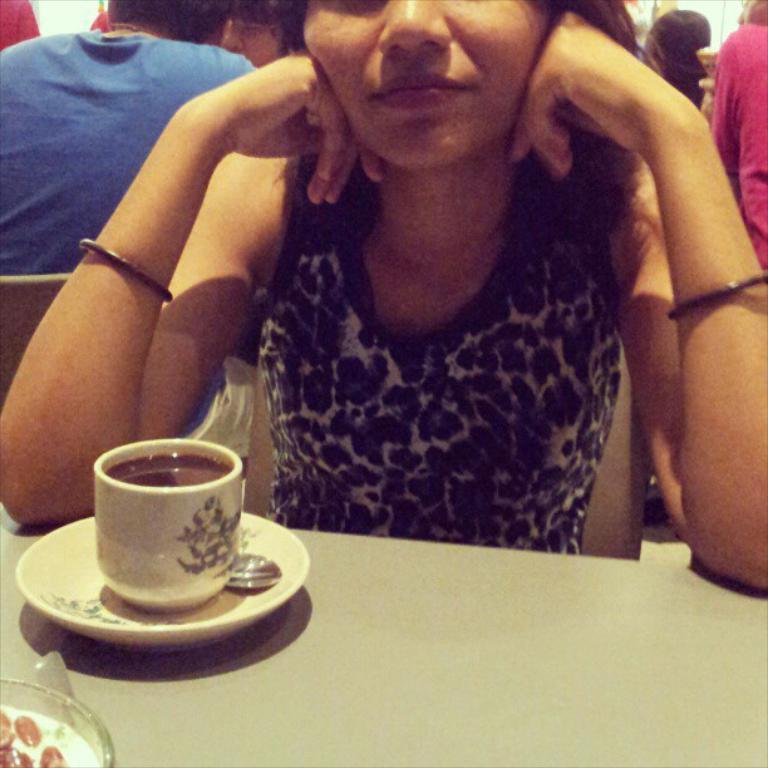What are the persons in the image doing? The persons in the image are sitting on chairs. What is located at the bottom of the image? There is a table at the bottom of the image. What items can be seen on the table? A coffee cup, a plate, and a spoon are present on the table. What type of quince is being used as a decoration on the table? There is no quince present on the table in the image. How does the cub interact with the coffee cup on the table? There is no cub present in the image; it only features persons sitting on chairs and items on the table. 